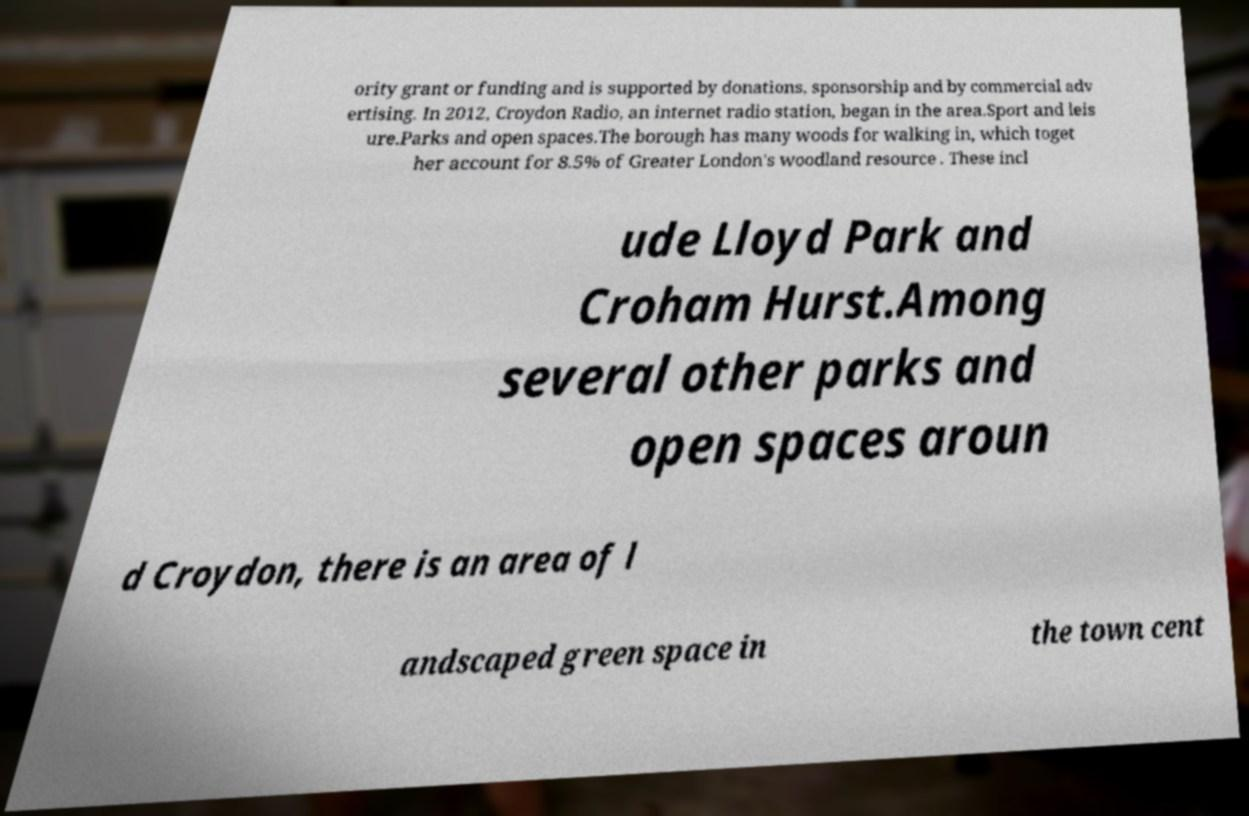I need the written content from this picture converted into text. Can you do that? ority grant or funding and is supported by donations, sponsorship and by commercial adv ertising. In 2012, Croydon Radio, an internet radio station, began in the area.Sport and leis ure.Parks and open spaces.The borough has many woods for walking in, which toget her account for 8.5% of Greater London's woodland resource . These incl ude Lloyd Park and Croham Hurst.Among several other parks and open spaces aroun d Croydon, there is an area of l andscaped green space in the town cent 